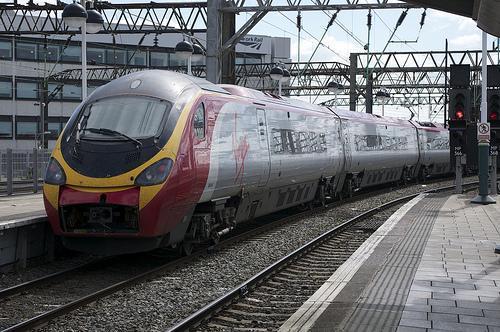How many train cars are there?
Give a very brief answer. 3. How many tracks have a train over them?
Give a very brief answer. 1. 